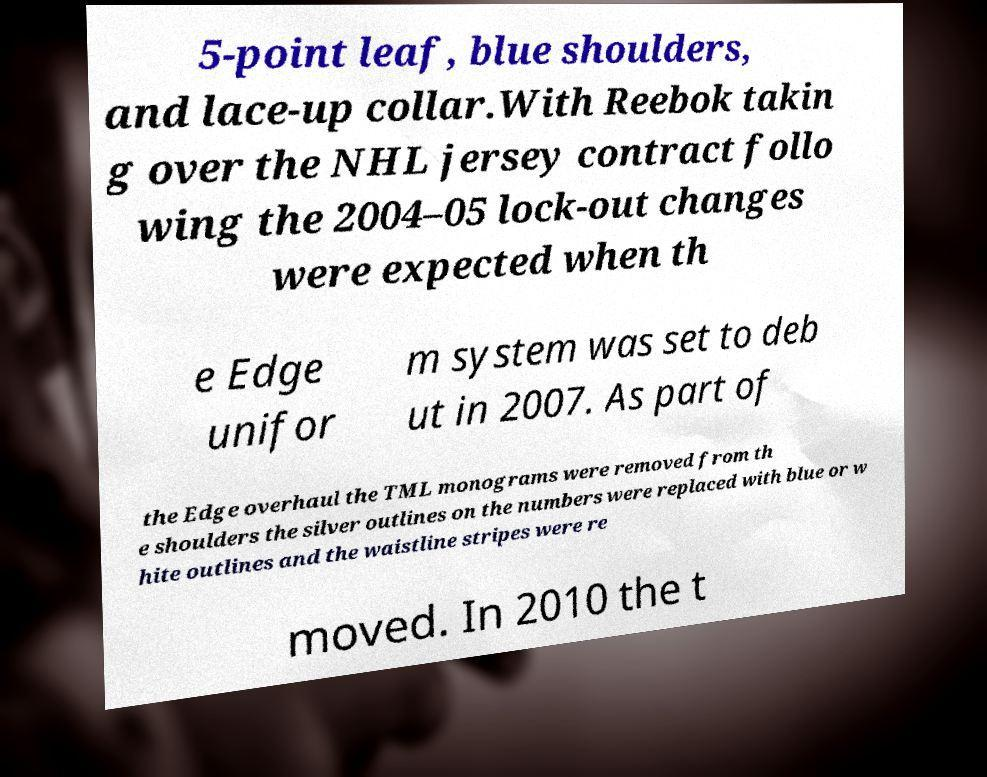What messages or text are displayed in this image? I need them in a readable, typed format. 5-point leaf, blue shoulders, and lace-up collar.With Reebok takin g over the NHL jersey contract follo wing the 2004–05 lock-out changes were expected when th e Edge unifor m system was set to deb ut in 2007. As part of the Edge overhaul the TML monograms were removed from th e shoulders the silver outlines on the numbers were replaced with blue or w hite outlines and the waistline stripes were re moved. In 2010 the t 